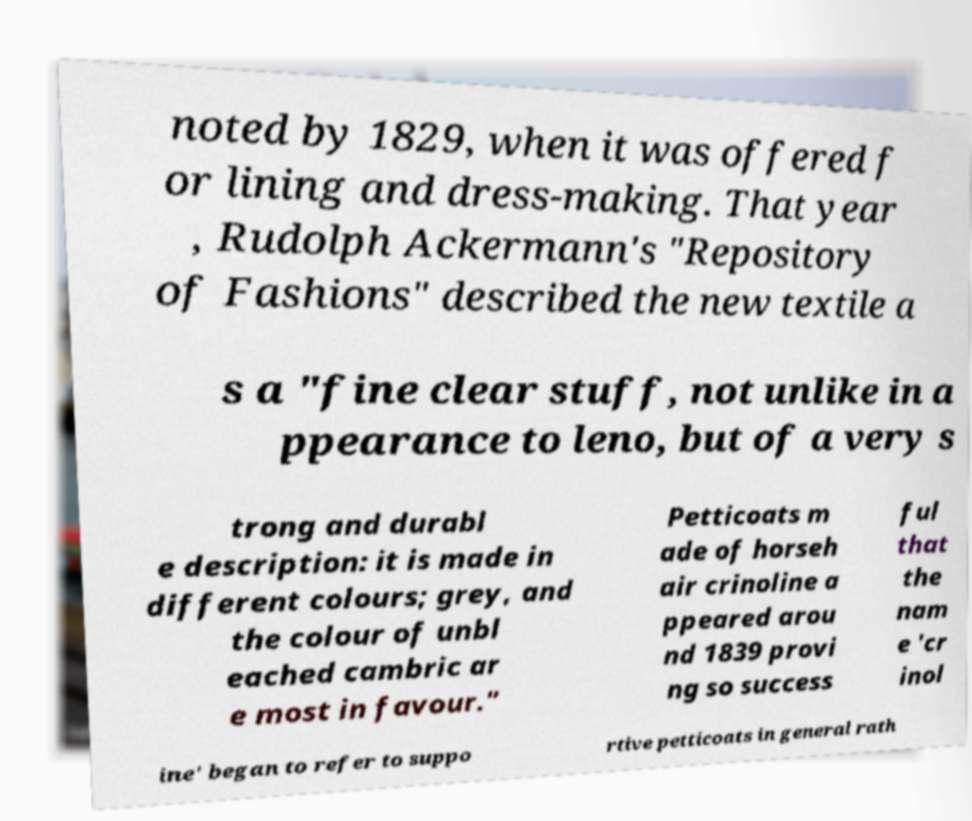I need the written content from this picture converted into text. Can you do that? noted by 1829, when it was offered f or lining and dress-making. That year , Rudolph Ackermann's "Repository of Fashions" described the new textile a s a "fine clear stuff, not unlike in a ppearance to leno, but of a very s trong and durabl e description: it is made in different colours; grey, and the colour of unbl eached cambric ar e most in favour." Petticoats m ade of horseh air crinoline a ppeared arou nd 1839 provi ng so success ful that the nam e 'cr inol ine' began to refer to suppo rtive petticoats in general rath 